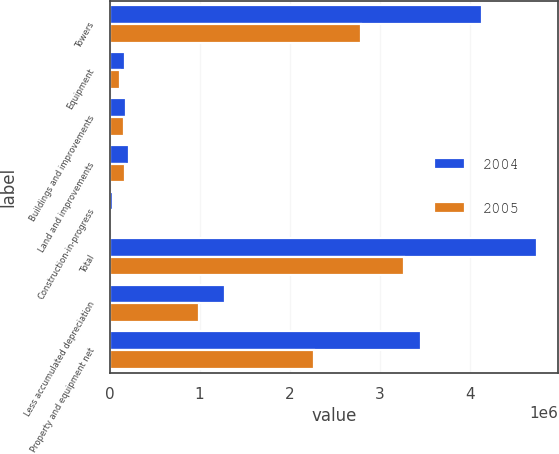Convert chart. <chart><loc_0><loc_0><loc_500><loc_500><stacked_bar_chart><ecel><fcel>Towers<fcel>Equipment<fcel>Buildings and improvements<fcel>Land and improvements<fcel>Construction-in-progress<fcel>Total<fcel>Less accumulated depreciation<fcel>Property and equipment net<nl><fcel>2004<fcel>4.13416e+06<fcel>167504<fcel>184951<fcel>215974<fcel>36991<fcel>4.73958e+06<fcel>1.27905e+06<fcel>3.46053e+06<nl><fcel>2005<fcel>2.78816e+06<fcel>115244<fcel>162120<fcel>176937<fcel>27866<fcel>3.27033e+06<fcel>996973<fcel>2.27336e+06<nl></chart> 